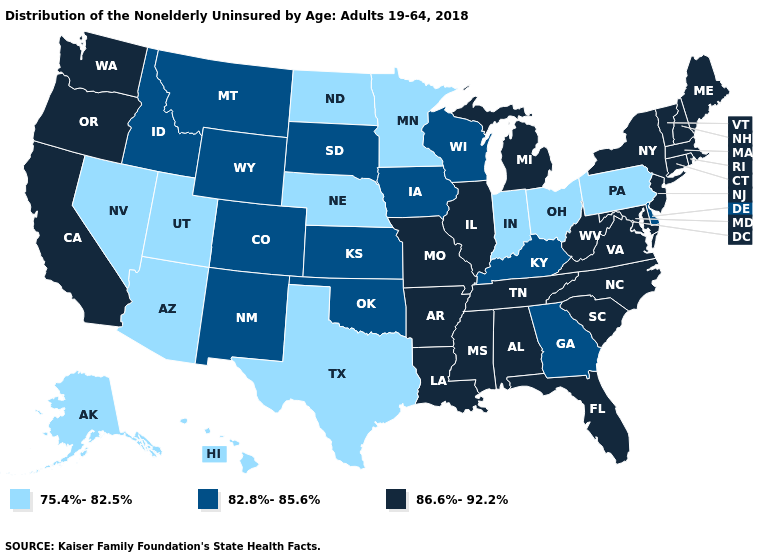Among the states that border Minnesota , does North Dakota have the highest value?
Be succinct. No. What is the lowest value in the USA?
Be succinct. 75.4%-82.5%. Does North Dakota have the lowest value in the USA?
Write a very short answer. Yes. Which states have the lowest value in the MidWest?
Write a very short answer. Indiana, Minnesota, Nebraska, North Dakota, Ohio. Name the states that have a value in the range 82.8%-85.6%?
Quick response, please. Colorado, Delaware, Georgia, Idaho, Iowa, Kansas, Kentucky, Montana, New Mexico, Oklahoma, South Dakota, Wisconsin, Wyoming. Name the states that have a value in the range 86.6%-92.2%?
Write a very short answer. Alabama, Arkansas, California, Connecticut, Florida, Illinois, Louisiana, Maine, Maryland, Massachusetts, Michigan, Mississippi, Missouri, New Hampshire, New Jersey, New York, North Carolina, Oregon, Rhode Island, South Carolina, Tennessee, Vermont, Virginia, Washington, West Virginia. Which states have the lowest value in the West?
Quick response, please. Alaska, Arizona, Hawaii, Nevada, Utah. Name the states that have a value in the range 86.6%-92.2%?
Give a very brief answer. Alabama, Arkansas, California, Connecticut, Florida, Illinois, Louisiana, Maine, Maryland, Massachusetts, Michigan, Mississippi, Missouri, New Hampshire, New Jersey, New York, North Carolina, Oregon, Rhode Island, South Carolina, Tennessee, Vermont, Virginia, Washington, West Virginia. Which states have the highest value in the USA?
Answer briefly. Alabama, Arkansas, California, Connecticut, Florida, Illinois, Louisiana, Maine, Maryland, Massachusetts, Michigan, Mississippi, Missouri, New Hampshire, New Jersey, New York, North Carolina, Oregon, Rhode Island, South Carolina, Tennessee, Vermont, Virginia, Washington, West Virginia. What is the highest value in states that border Missouri?
Keep it brief. 86.6%-92.2%. What is the highest value in the West ?
Be succinct. 86.6%-92.2%. Among the states that border North Carolina , does Georgia have the highest value?
Give a very brief answer. No. 